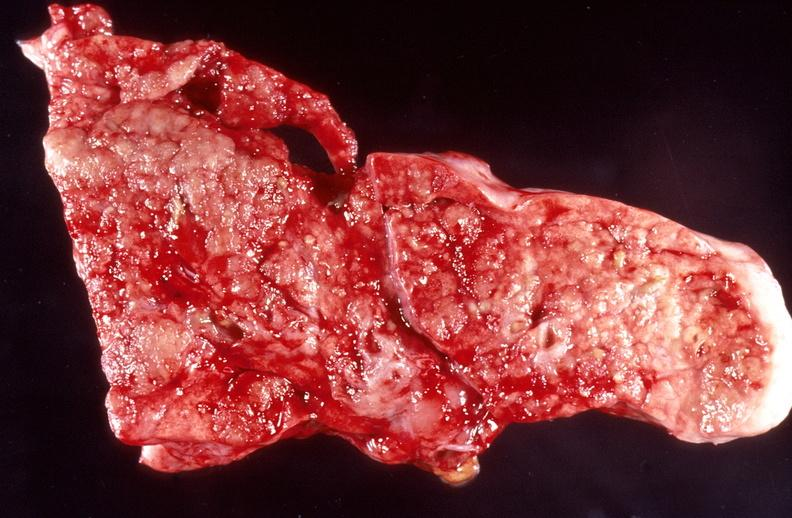where is this?
Answer the question using a single word or phrase. Lung 